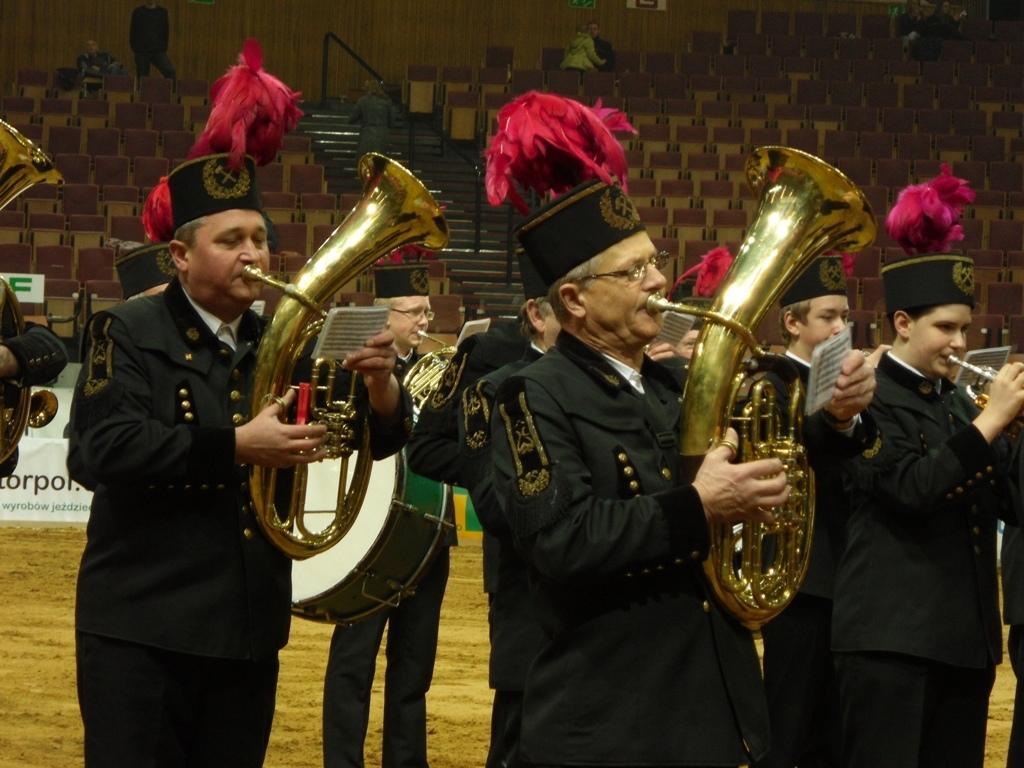Can you describe this image briefly? In this image I can see number of people are standing and I can see all of them are holding musical instruments and papers. I can also see something is written on these papers and I can see all of them are wearing same colour of dress. In the background I can see two white colour boards, number of chairs, a railing, stairs, few more people and on these boards I can see something is written. 